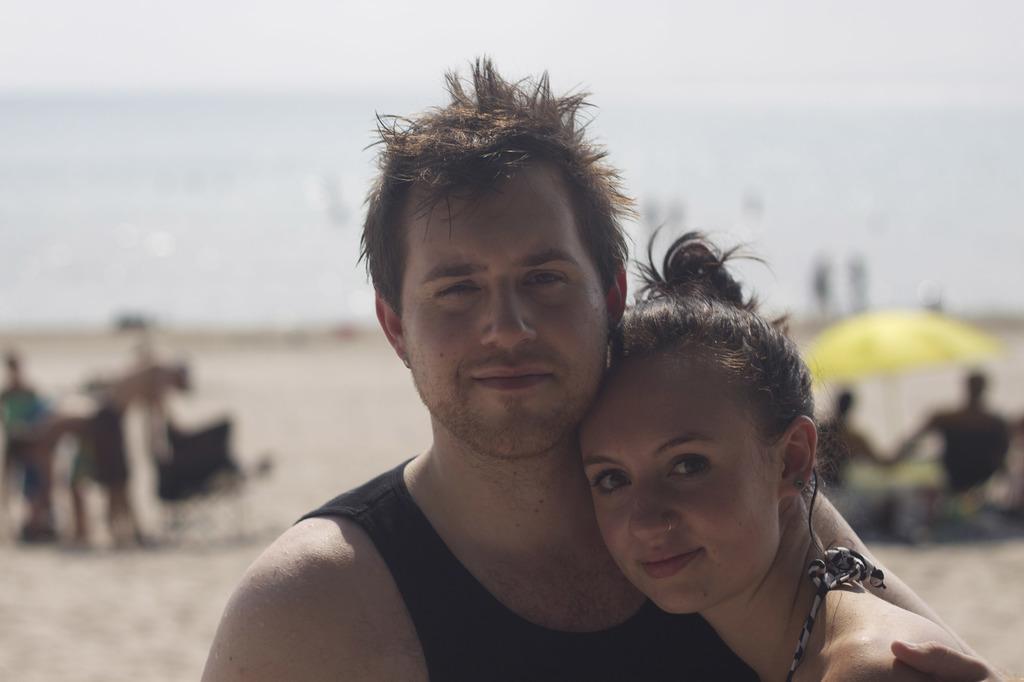How would you summarize this image in a sentence or two? In this image there is a couple in the middle. There is a man on the left side and a woman on the right side. In the background there is a yellow colour umbrella under which there are two persons. At the bottom there is sand. 